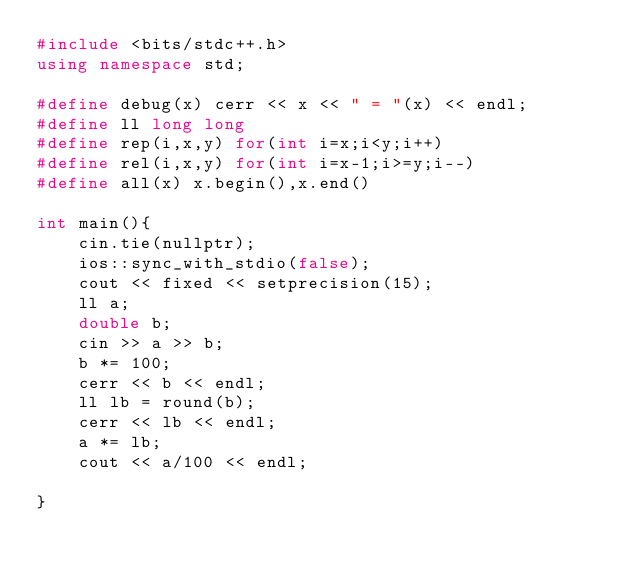<code> <loc_0><loc_0><loc_500><loc_500><_C++_>#include <bits/stdc++.h>
using namespace std;

#define debug(x) cerr << x << " = "(x) << endl;
#define ll long long
#define rep(i,x,y) for(int i=x;i<y;i++)
#define rel(i,x,y) for(int i=x-1;i>=y;i--)
#define all(x) x.begin(),x.end()

int main(){
    cin.tie(nullptr);
    ios::sync_with_stdio(false);
    cout << fixed << setprecision(15);
    ll a;
    double b;
    cin >> a >> b;
    b *= 100;
    cerr << b << endl;
    ll lb = round(b);
    cerr << lb << endl;
    a *= lb;
    cout << a/100 << endl;

}</code> 